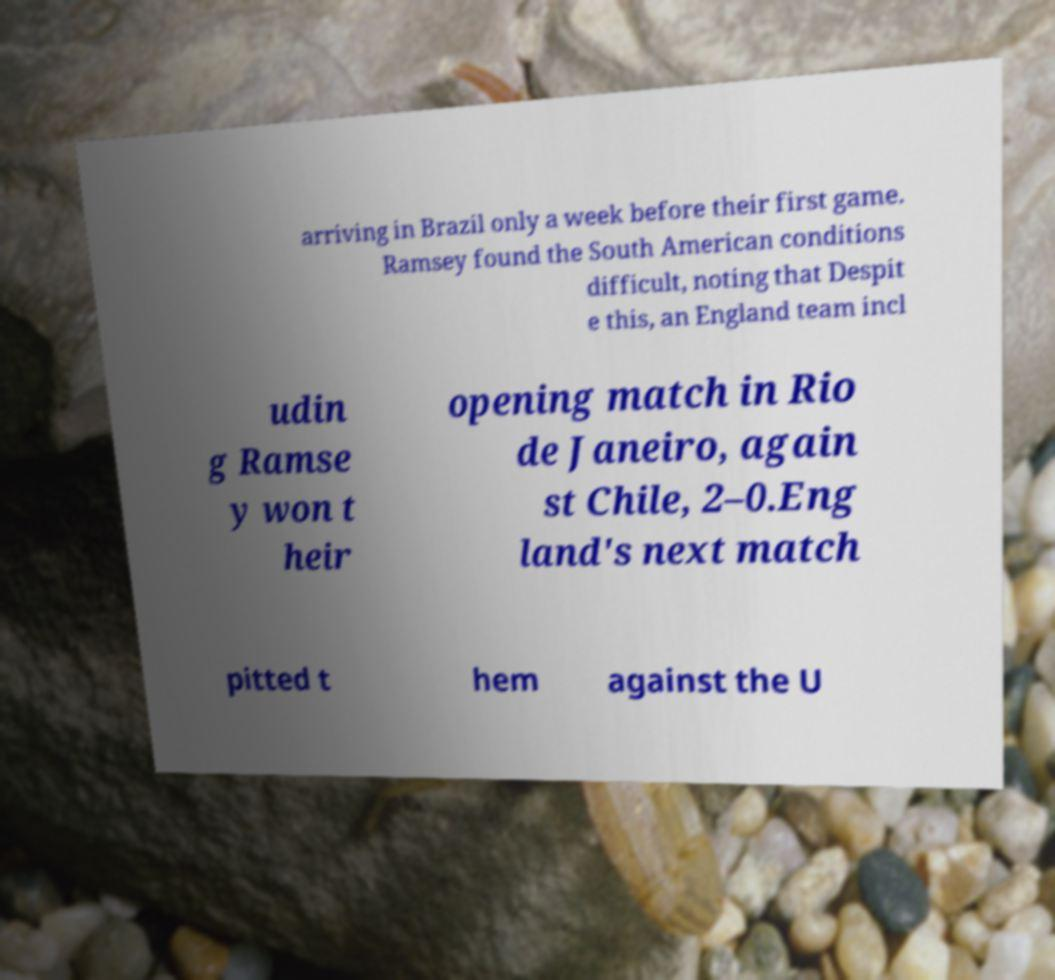Please read and relay the text visible in this image. What does it say? arriving in Brazil only a week before their first game. Ramsey found the South American conditions difficult, noting that Despit e this, an England team incl udin g Ramse y won t heir opening match in Rio de Janeiro, again st Chile, 2–0.Eng land's next match pitted t hem against the U 